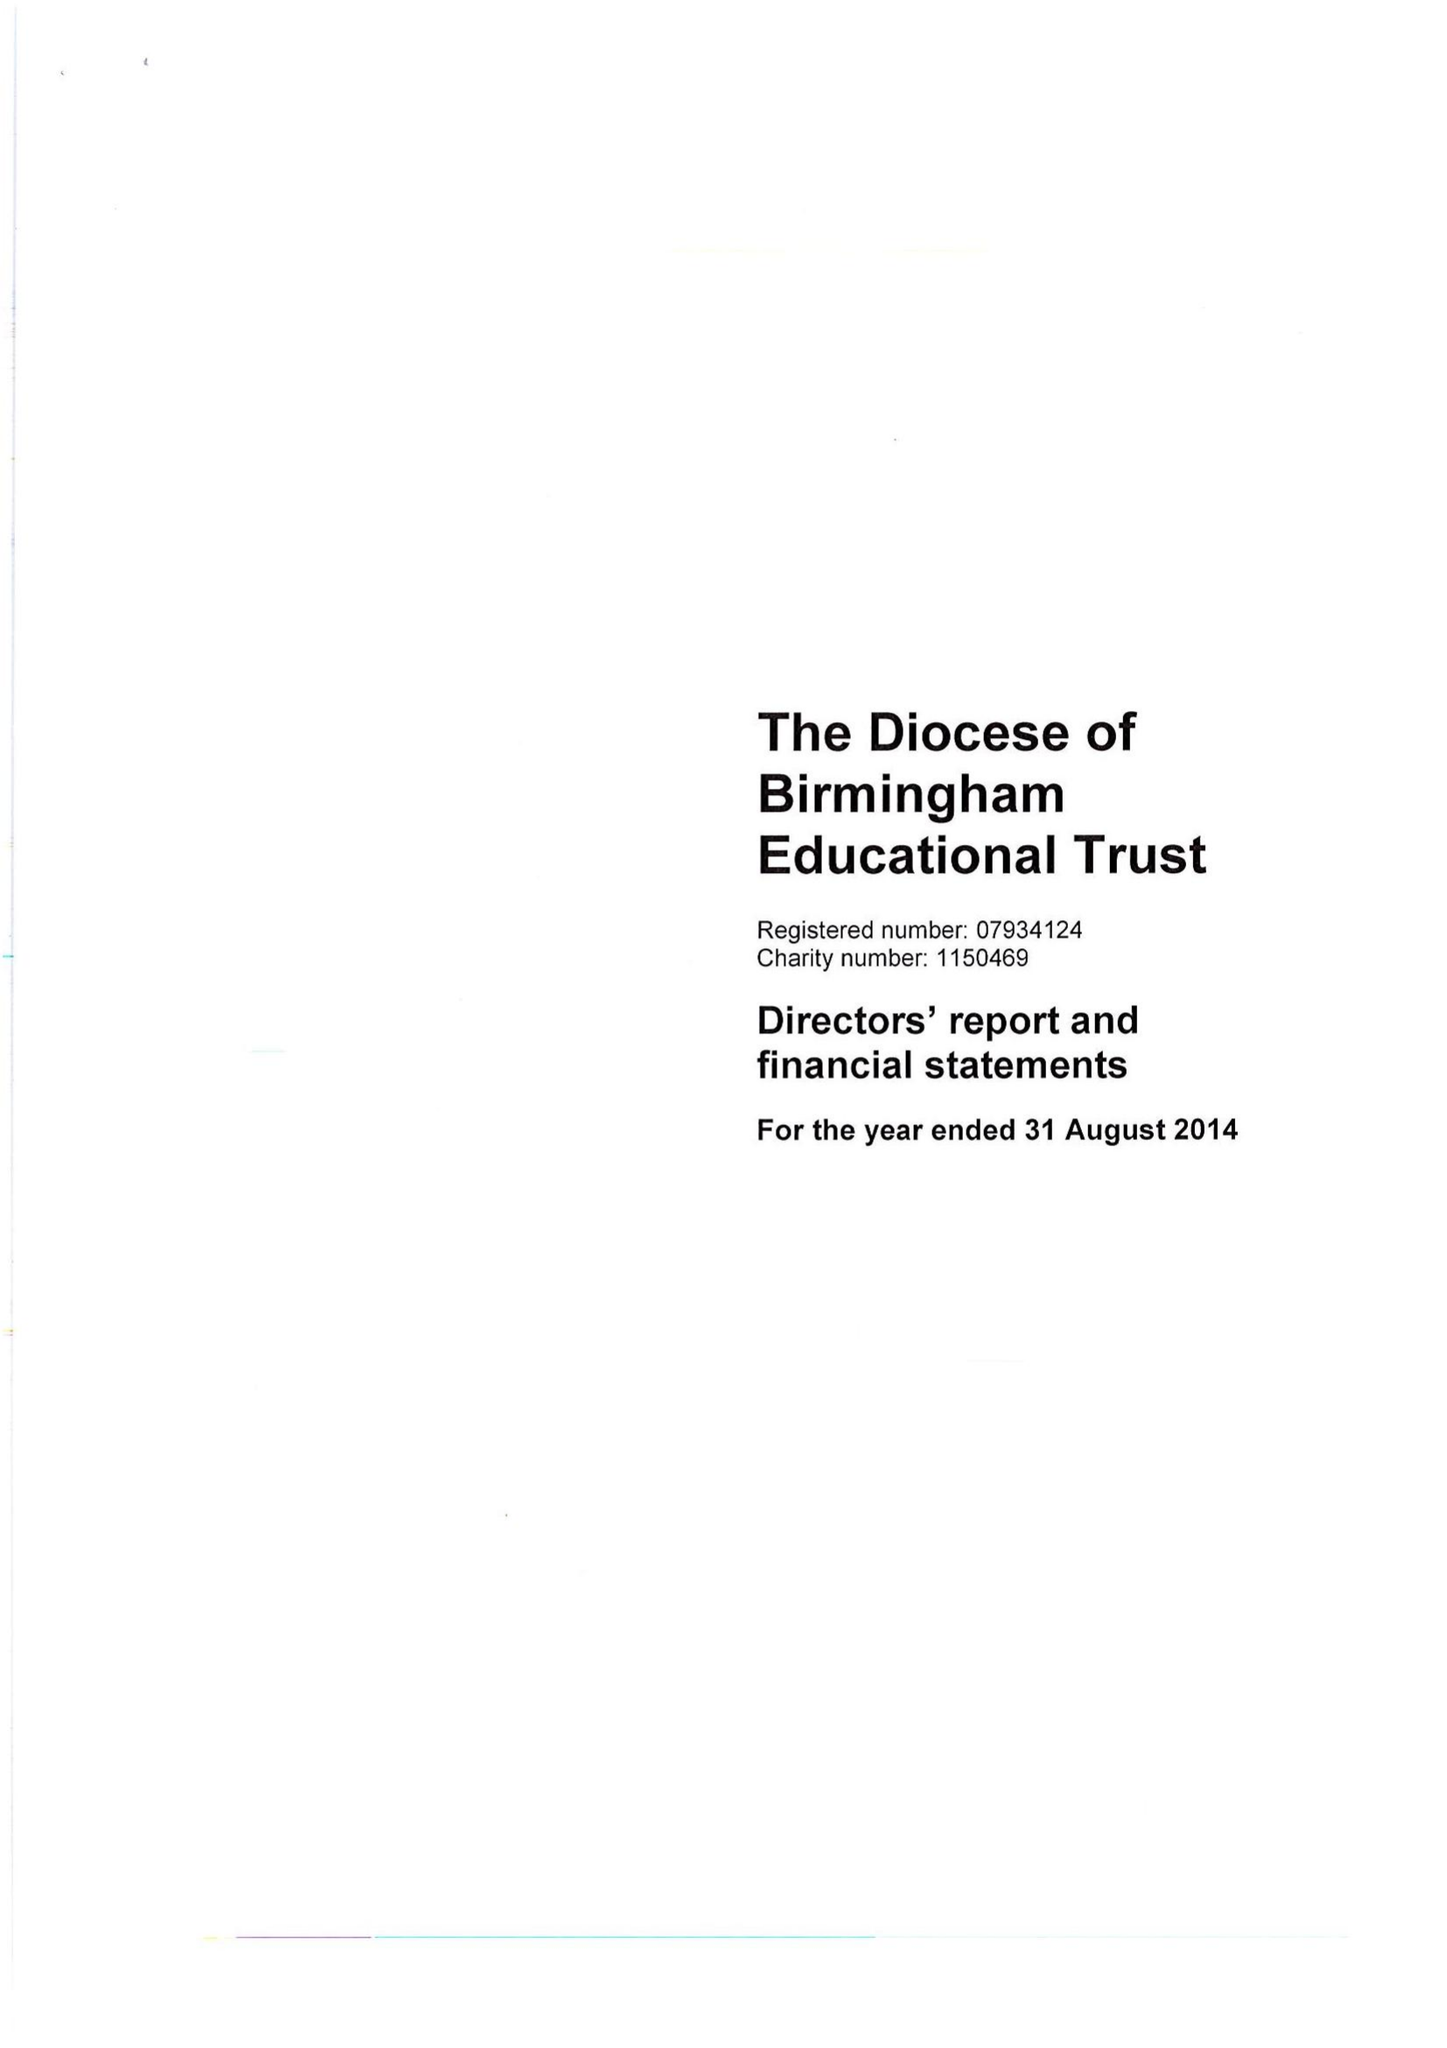What is the value for the income_annually_in_british_pounds?
Answer the question using a single word or phrase. 166700.00 